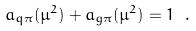Convert formula to latex. <formula><loc_0><loc_0><loc_500><loc_500>a _ { q \pi } ( \mu ^ { 2 } ) + a _ { g \pi } ( \mu ^ { 2 } ) = 1 \ .</formula> 